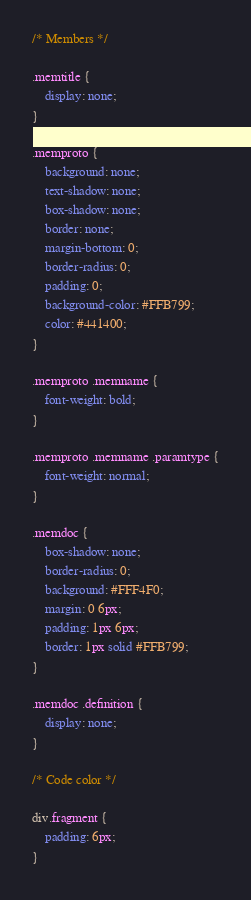Convert code to text. <code><loc_0><loc_0><loc_500><loc_500><_CSS_>/* Members */

.memtitle {
    display: none;
}

.memproto {
    background: none;
    text-shadow: none;
    box-shadow: none;
    border: none;
    margin-bottom: 0;
    border-radius: 0;
    padding: 0;
    background-color: #FFB799;
    color: #441400;
}

.memproto .memname {
    font-weight: bold;
}

.memproto .memname .paramtype {
    font-weight: normal;
}

.memdoc {    
    box-shadow: none;
    border-radius: 0;
    background: #FFF4F0;
    margin: 0 6px;
    padding: 1px 6px;
    border: 1px solid #FFB799;
}

.memdoc .definition {
    display: none;
}

/* Code color */

div.fragment {
    padding: 6px;
}
</code> 